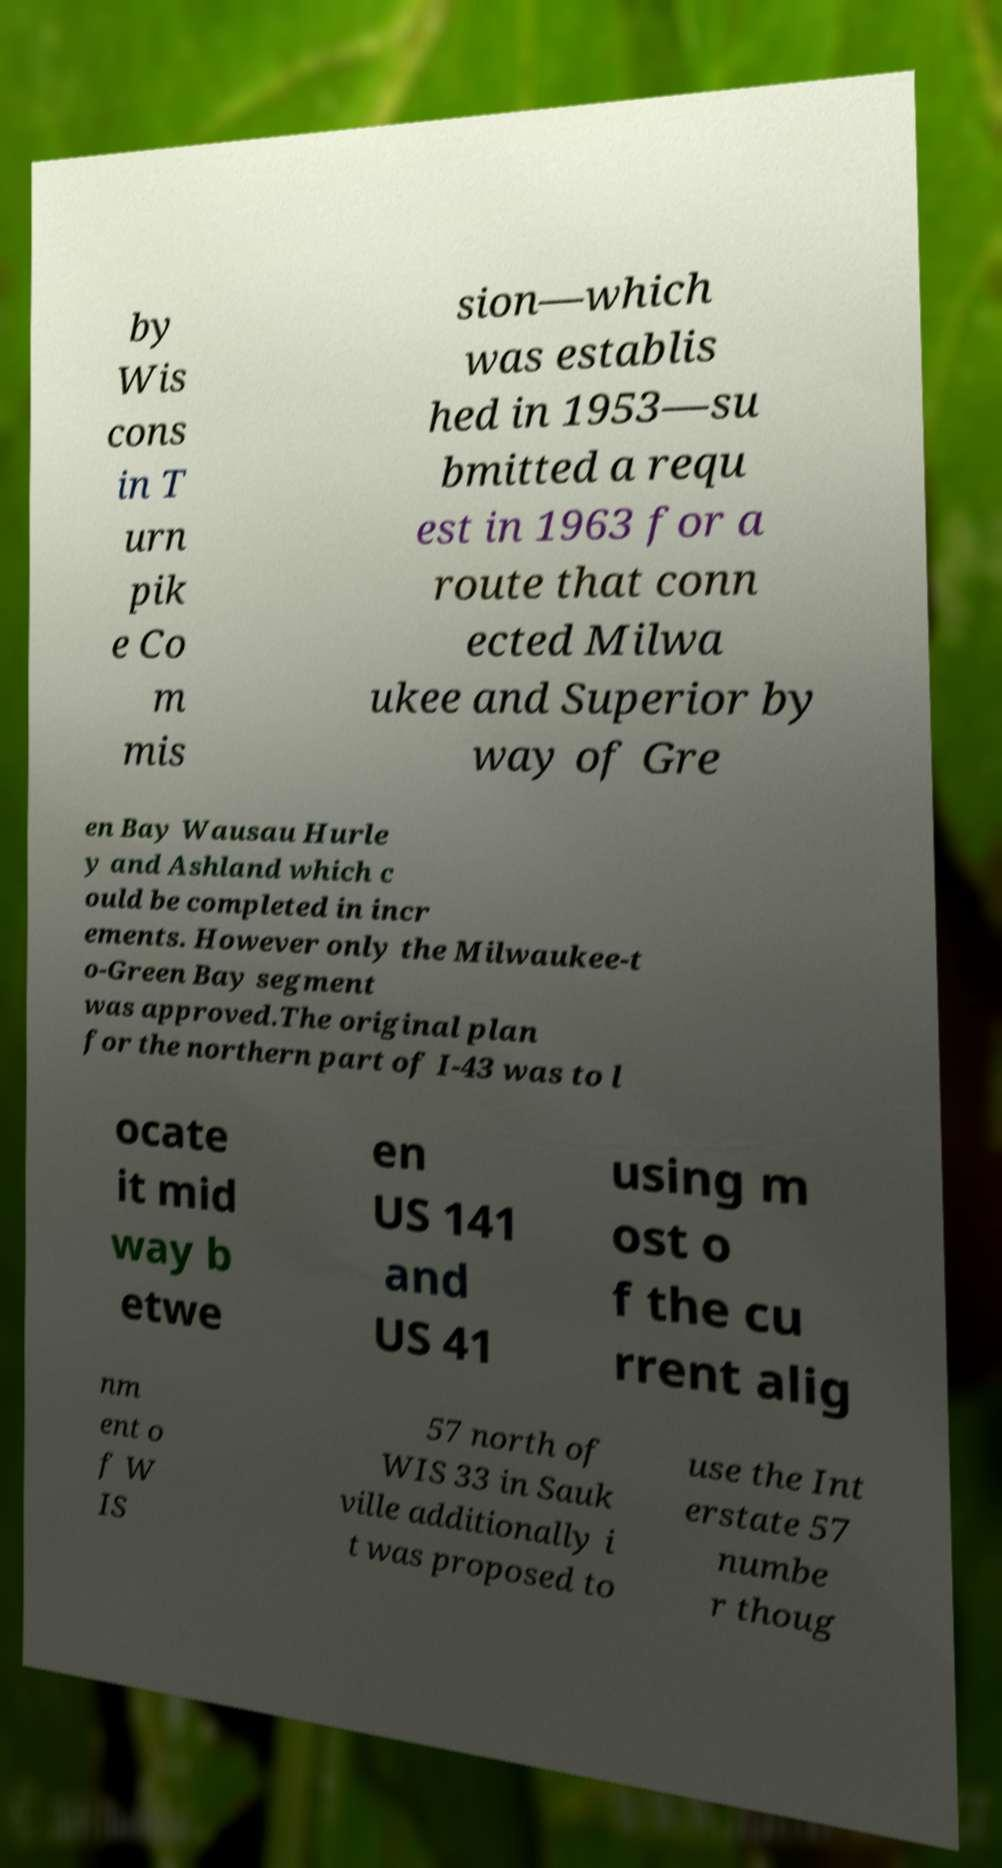Can you read and provide the text displayed in the image?This photo seems to have some interesting text. Can you extract and type it out for me? by Wis cons in T urn pik e Co m mis sion—which was establis hed in 1953—su bmitted a requ est in 1963 for a route that conn ected Milwa ukee and Superior by way of Gre en Bay Wausau Hurle y and Ashland which c ould be completed in incr ements. However only the Milwaukee-t o-Green Bay segment was approved.The original plan for the northern part of I-43 was to l ocate it mid way b etwe en US 141 and US 41 using m ost o f the cu rrent alig nm ent o f W IS 57 north of WIS 33 in Sauk ville additionally i t was proposed to use the Int erstate 57 numbe r thoug 